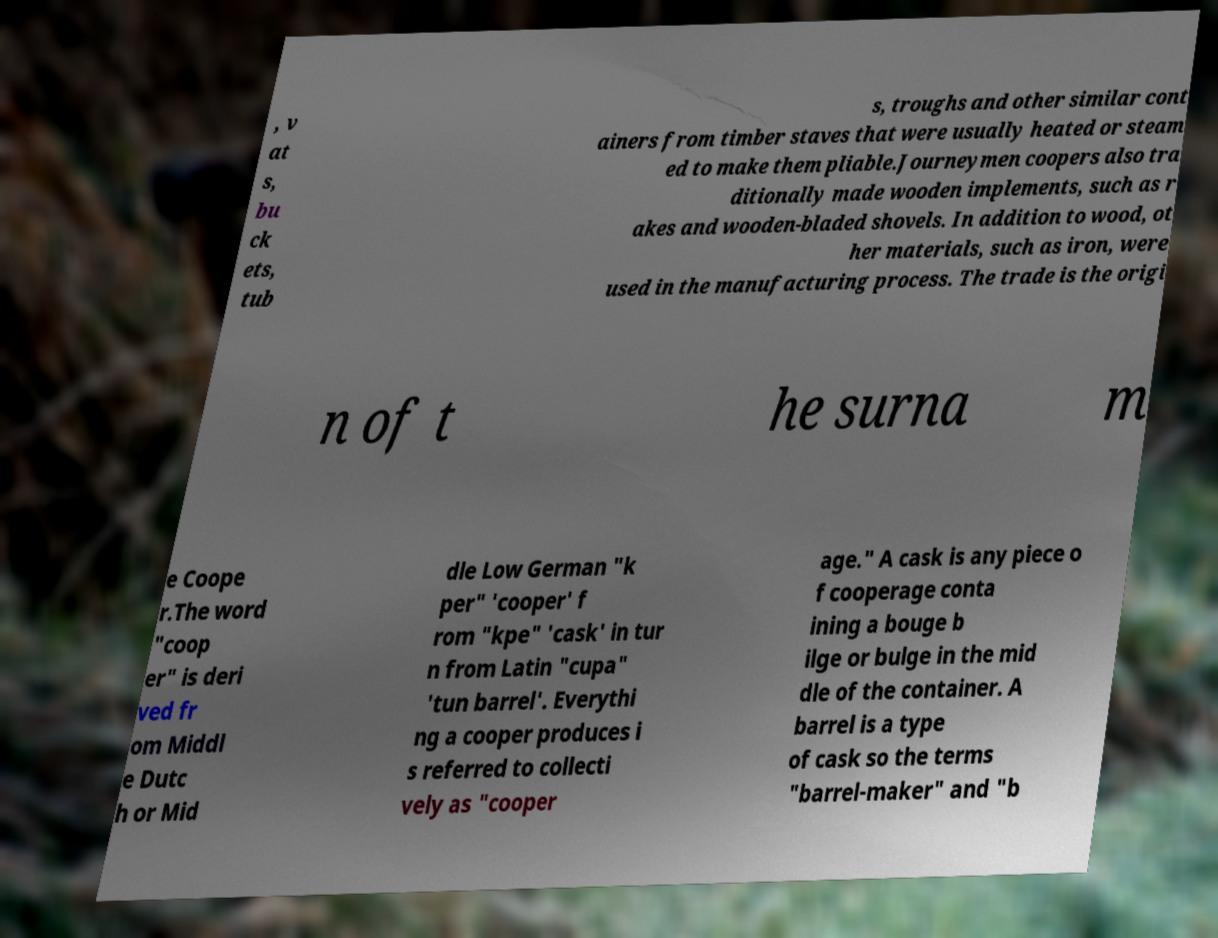Can you accurately transcribe the text from the provided image for me? , v at s, bu ck ets, tub s, troughs and other similar cont ainers from timber staves that were usually heated or steam ed to make them pliable.Journeymen coopers also tra ditionally made wooden implements, such as r akes and wooden-bladed shovels. In addition to wood, ot her materials, such as iron, were used in the manufacturing process. The trade is the origi n of t he surna m e Coope r.The word "coop er" is deri ved fr om Middl e Dutc h or Mid dle Low German "k per" 'cooper' f rom "kpe" 'cask' in tur n from Latin "cupa" 'tun barrel'. Everythi ng a cooper produces i s referred to collecti vely as "cooper age." A cask is any piece o f cooperage conta ining a bouge b ilge or bulge in the mid dle of the container. A barrel is a type of cask so the terms "barrel-maker" and "b 